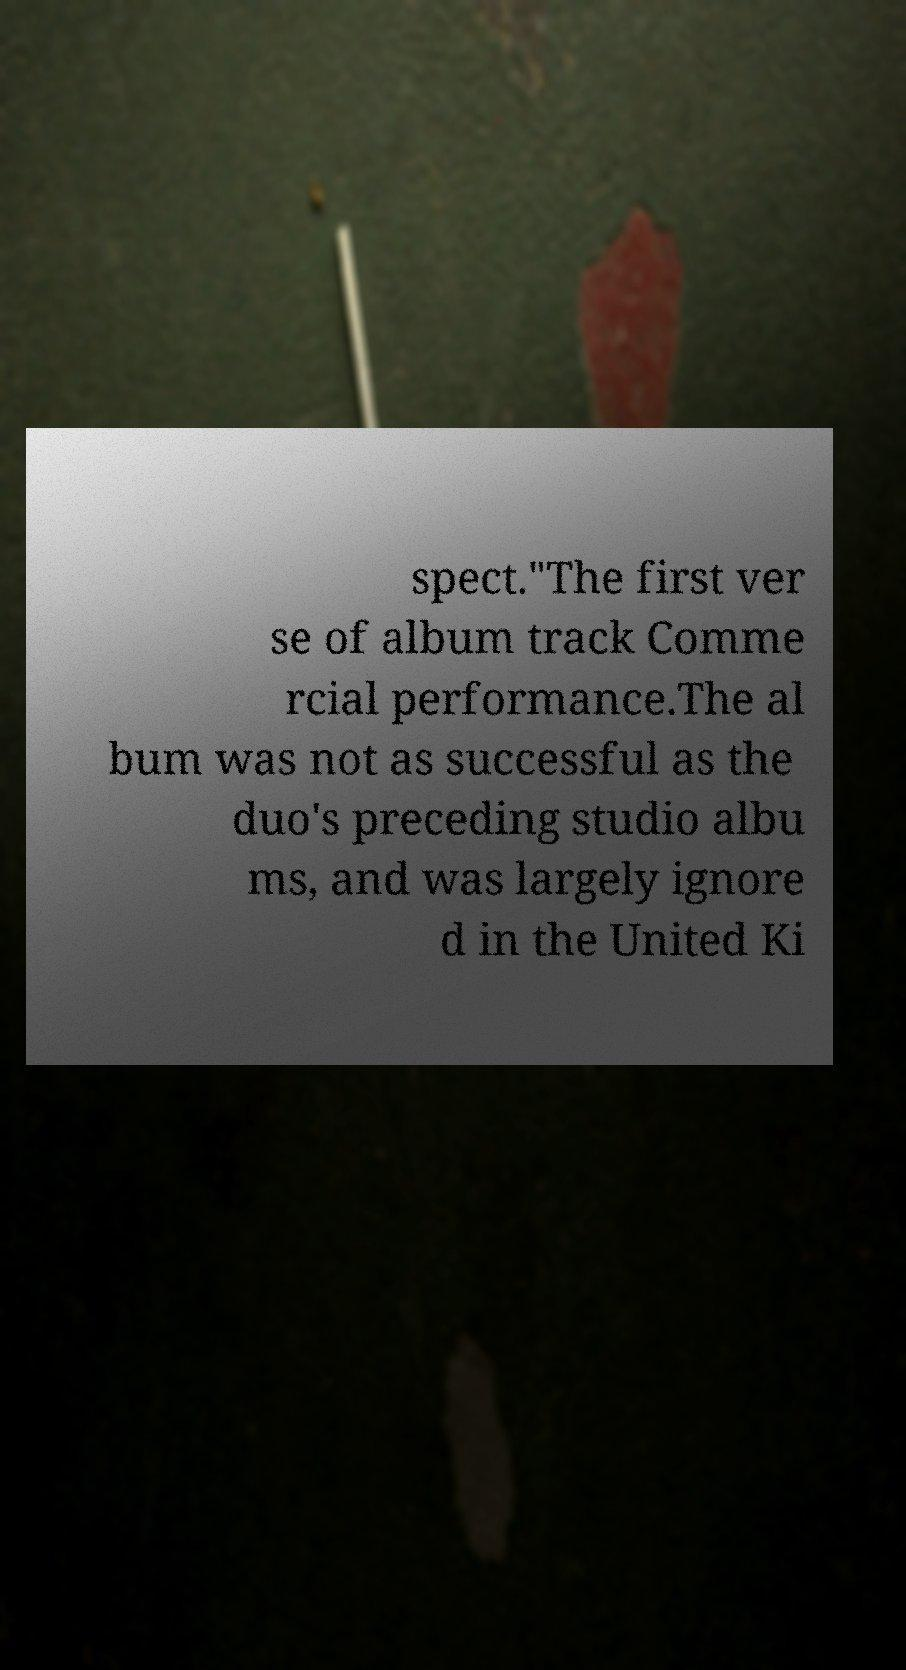Please read and relay the text visible in this image. What does it say? spect."The first ver se of album track Comme rcial performance.The al bum was not as successful as the duo's preceding studio albu ms, and was largely ignore d in the United Ki 